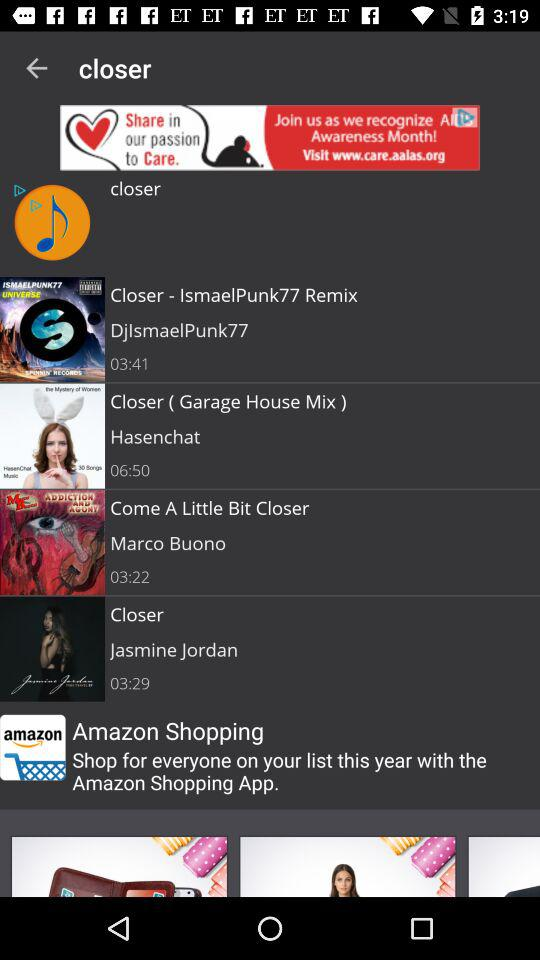Which song was sung by Hasenchat? Hasenchat sang "Closer ( Garage House Mix )". 